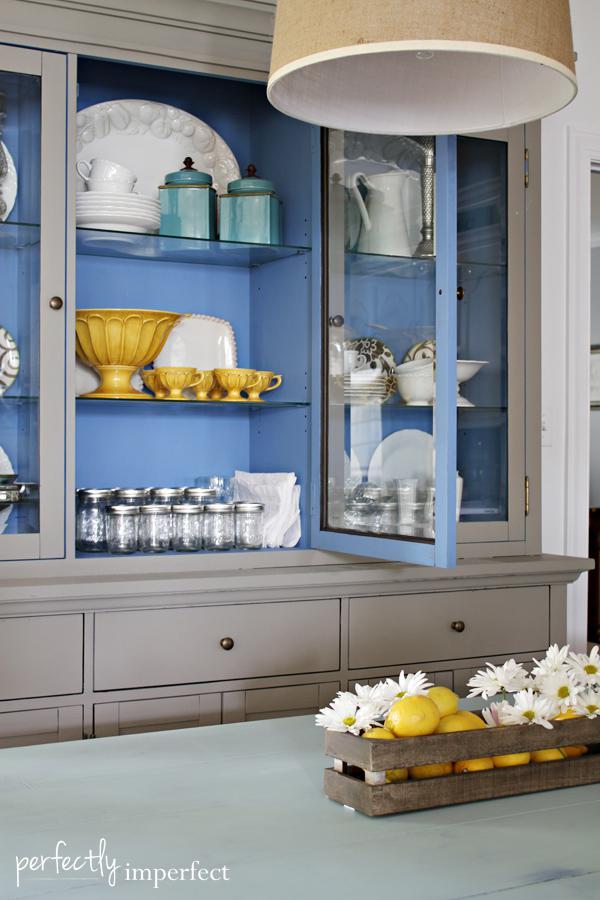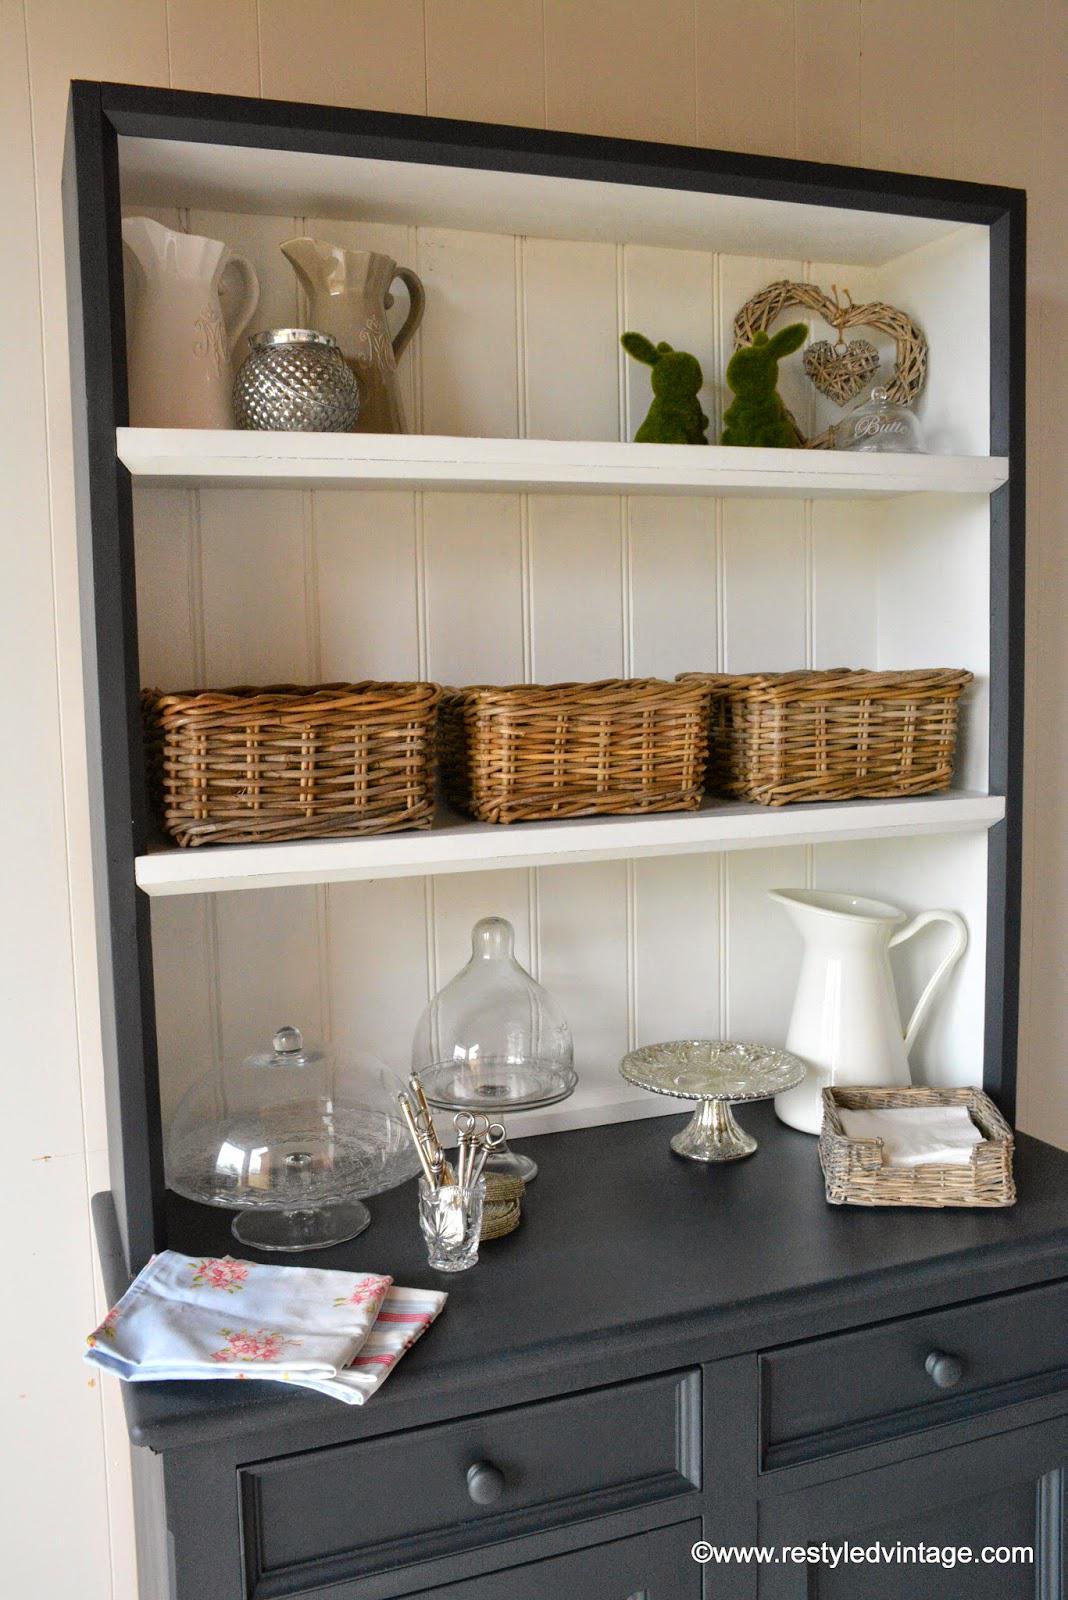The first image is the image on the left, the second image is the image on the right. For the images displayed, is the sentence "there is a bookshelf on a wood floor and a vase of flowers on top" factually correct? Answer yes or no. No. The first image is the image on the left, the second image is the image on the right. Evaluate the accuracy of this statement regarding the images: "In one image a bookshelf with four levels has a decorative inner arc framing the upper shelf on which a clock is sitting.". Is it true? Answer yes or no. No. 